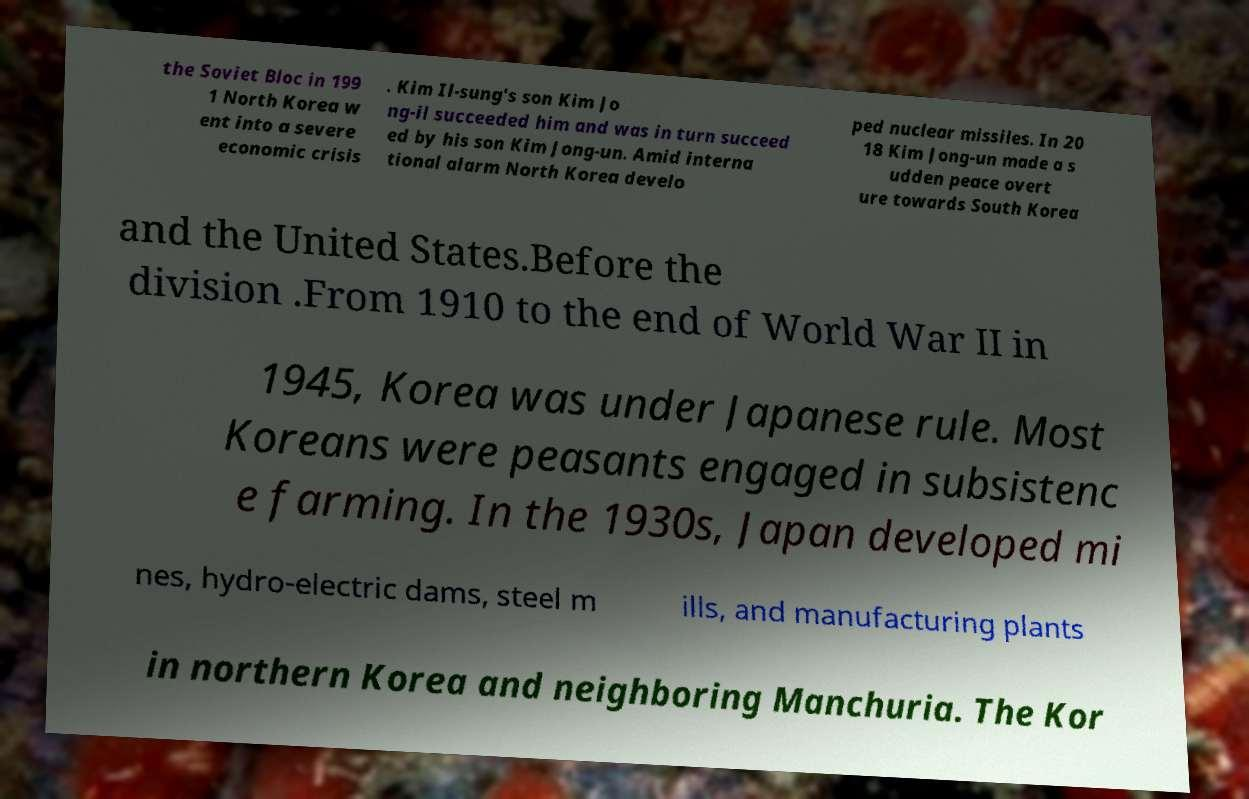Could you assist in decoding the text presented in this image and type it out clearly? the Soviet Bloc in 199 1 North Korea w ent into a severe economic crisis . Kim Il-sung's son Kim Jo ng-il succeeded him and was in turn succeed ed by his son Kim Jong-un. Amid interna tional alarm North Korea develo ped nuclear missiles. In 20 18 Kim Jong-un made a s udden peace overt ure towards South Korea and the United States.Before the division .From 1910 to the end of World War II in 1945, Korea was under Japanese rule. Most Koreans were peasants engaged in subsistenc e farming. In the 1930s, Japan developed mi nes, hydro-electric dams, steel m ills, and manufacturing plants in northern Korea and neighboring Manchuria. The Kor 